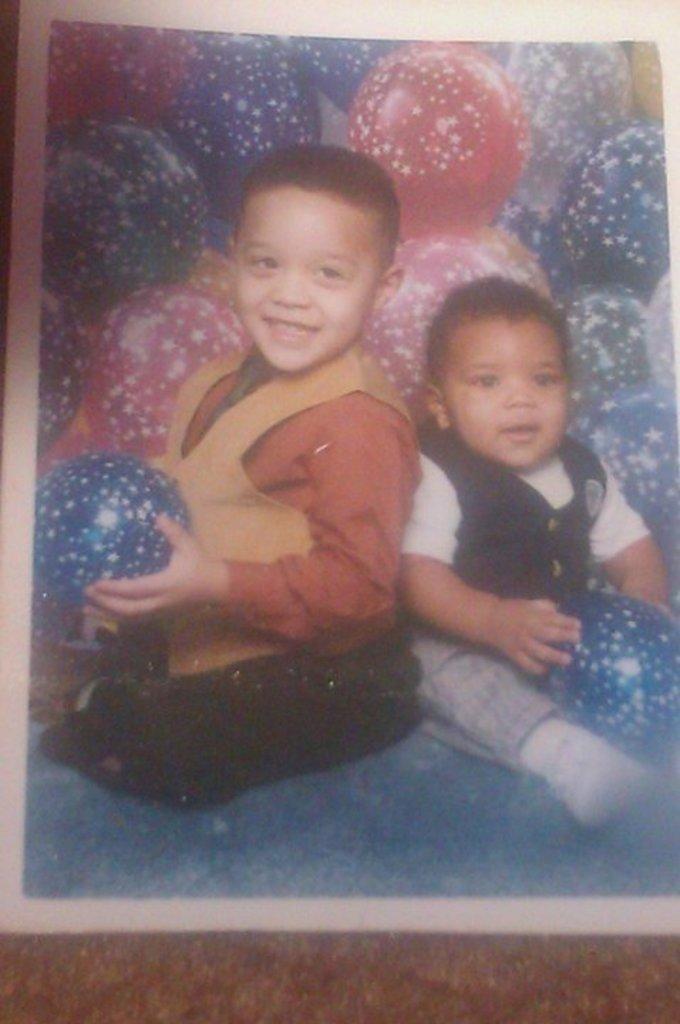How would you summarize this image in a sentence or two? In the picture we can see a photograph of two small boys sitting together and holding balls in their hands, and behind them we can see many balls which are blue in color and some are pink in color. 